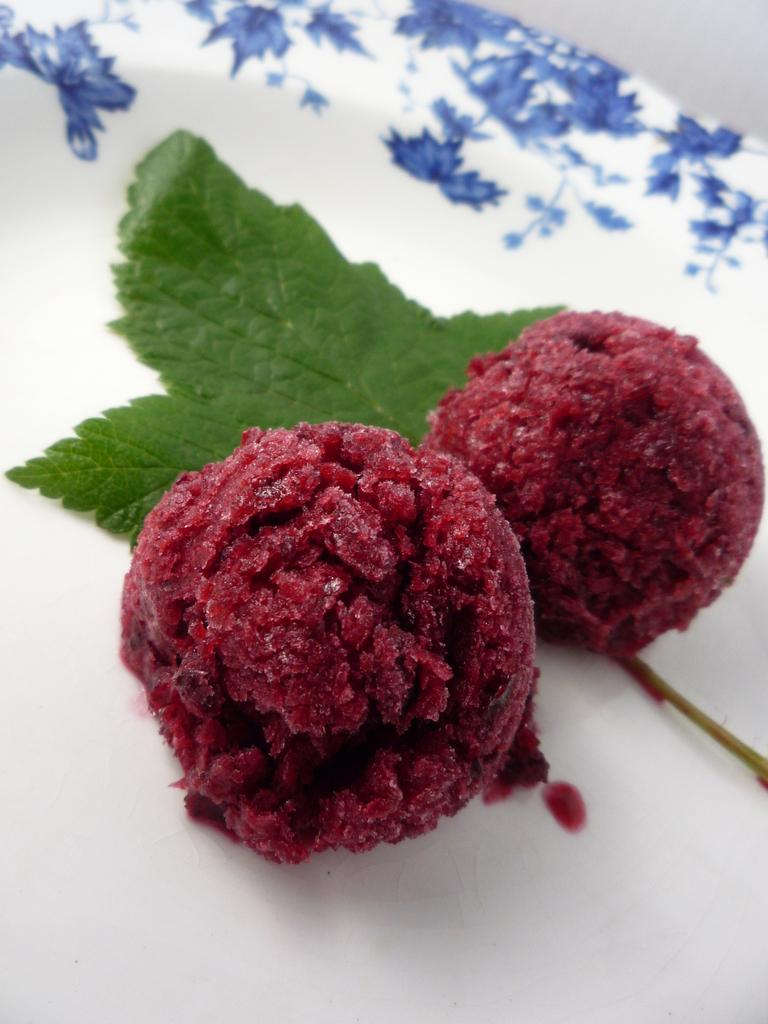What is the primary object in the image? There is a leaf in the image. What else can be seen in the image besides the leaf? There are food items on a white plate in the image. What type of rule is being enforced in the image? There is no rule or enforcement present in the image; it features a leaf and food items on a plate. Can you tell me where the church is located in the image? There is no church present in the image. 